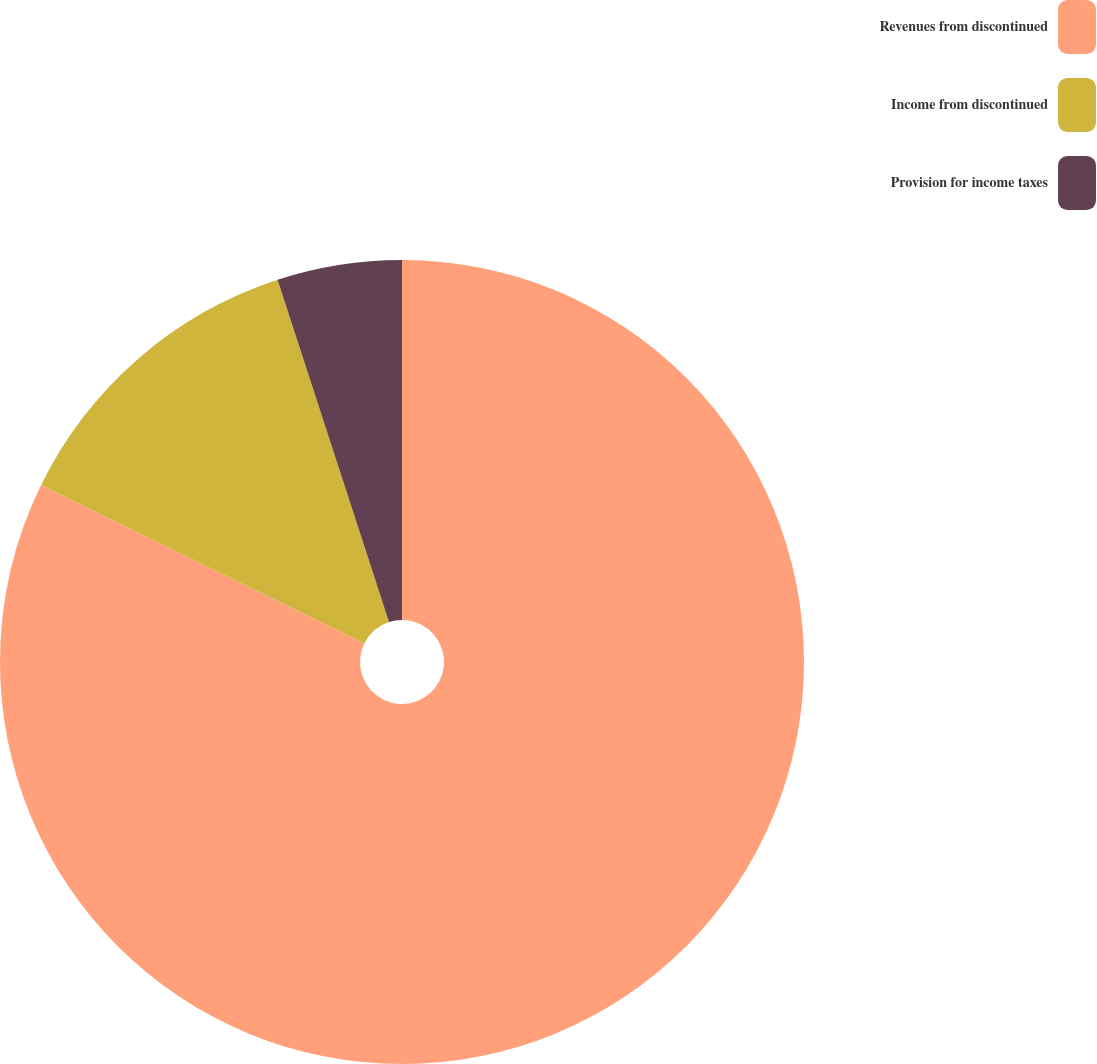Convert chart. <chart><loc_0><loc_0><loc_500><loc_500><pie_chart><fcel>Revenues from discontinued<fcel>Income from discontinued<fcel>Provision for income taxes<nl><fcel>82.26%<fcel>12.73%<fcel>5.01%<nl></chart> 